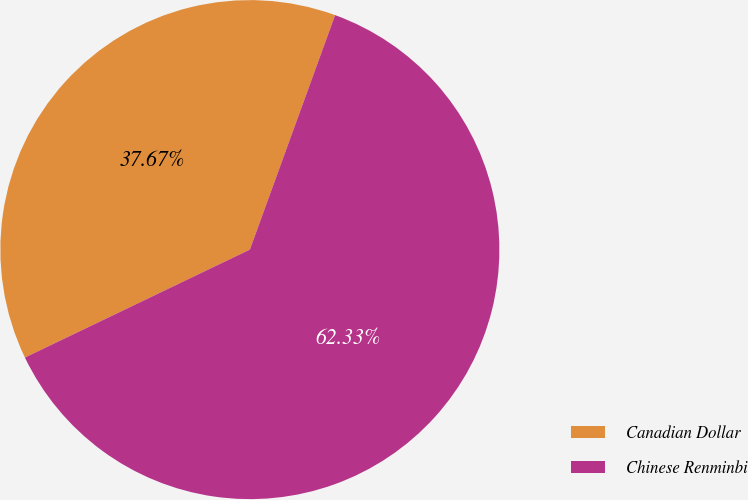Convert chart. <chart><loc_0><loc_0><loc_500><loc_500><pie_chart><fcel>Canadian Dollar<fcel>Chinese Renminbi<nl><fcel>37.67%<fcel>62.33%<nl></chart> 